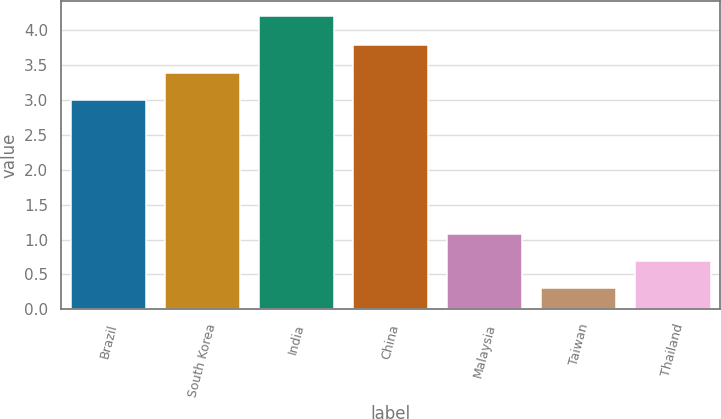Convert chart. <chart><loc_0><loc_0><loc_500><loc_500><bar_chart><fcel>Brazil<fcel>South Korea<fcel>India<fcel>China<fcel>Malaysia<fcel>Taiwan<fcel>Thailand<nl><fcel>3<fcel>3.39<fcel>4.2<fcel>3.78<fcel>1.08<fcel>0.3<fcel>0.69<nl></chart> 